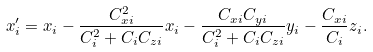Convert formula to latex. <formula><loc_0><loc_0><loc_500><loc_500>x ^ { \prime } _ { i } = x _ { i } - \frac { C _ { x i } ^ { 2 } } { C _ { i } ^ { 2 } + C _ { i } C _ { z i } } x _ { i } - \frac { C _ { x i } C _ { y i } } { C _ { i } ^ { 2 } + C _ { i } C _ { z i } } y _ { i } - \frac { C _ { x i } } { C _ { i } } z _ { i } .</formula> 